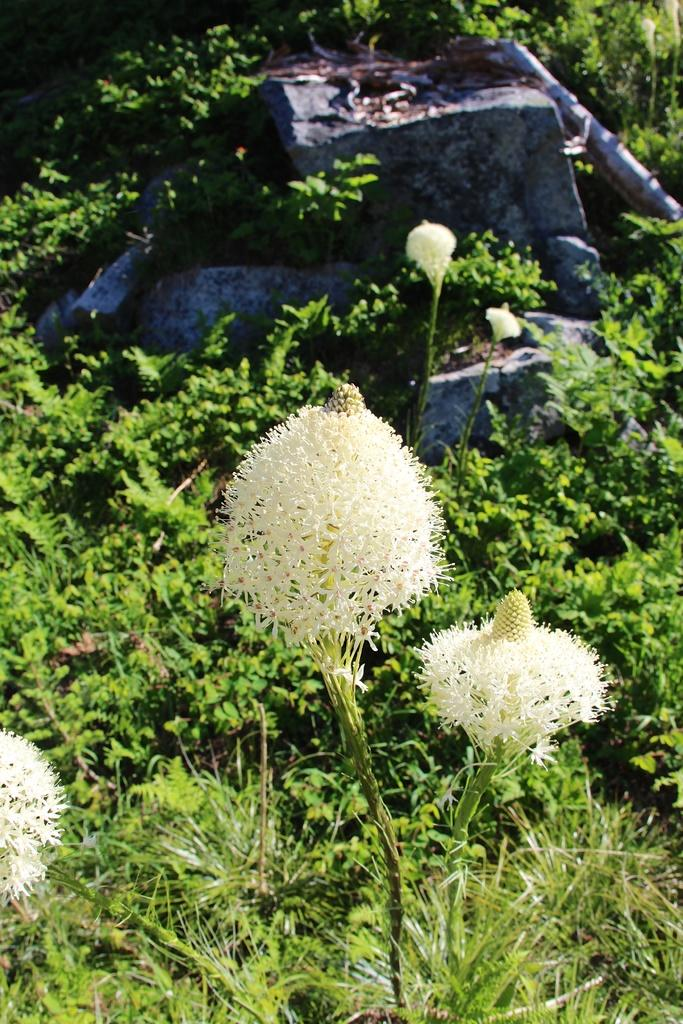What types of living organisms can be seen in the image? Plants and flowers are visible in the image. What other objects can be seen in the image besides plants and flowers? There are stones in the image. What type of pies are being baked in the image? There are no pies present in the image. What is the birth date of the person in the image? There is no person in the image, so it is not possible to determine their birth date. 